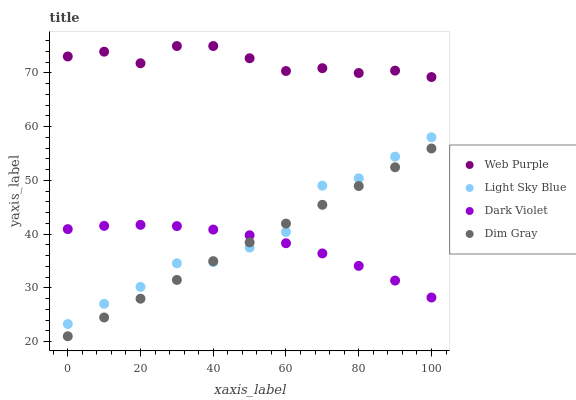Does Dark Violet have the minimum area under the curve?
Answer yes or no. Yes. Does Web Purple have the maximum area under the curve?
Answer yes or no. Yes. Does Light Sky Blue have the minimum area under the curve?
Answer yes or no. No. Does Light Sky Blue have the maximum area under the curve?
Answer yes or no. No. Is Dim Gray the smoothest?
Answer yes or no. Yes. Is Light Sky Blue the roughest?
Answer yes or no. Yes. Is Web Purple the smoothest?
Answer yes or no. No. Is Web Purple the roughest?
Answer yes or no. No. Does Dim Gray have the lowest value?
Answer yes or no. Yes. Does Light Sky Blue have the lowest value?
Answer yes or no. No. Does Web Purple have the highest value?
Answer yes or no. Yes. Does Light Sky Blue have the highest value?
Answer yes or no. No. Is Dim Gray less than Web Purple?
Answer yes or no. Yes. Is Web Purple greater than Dim Gray?
Answer yes or no. Yes. Does Dark Violet intersect Light Sky Blue?
Answer yes or no. Yes. Is Dark Violet less than Light Sky Blue?
Answer yes or no. No. Is Dark Violet greater than Light Sky Blue?
Answer yes or no. No. Does Dim Gray intersect Web Purple?
Answer yes or no. No. 